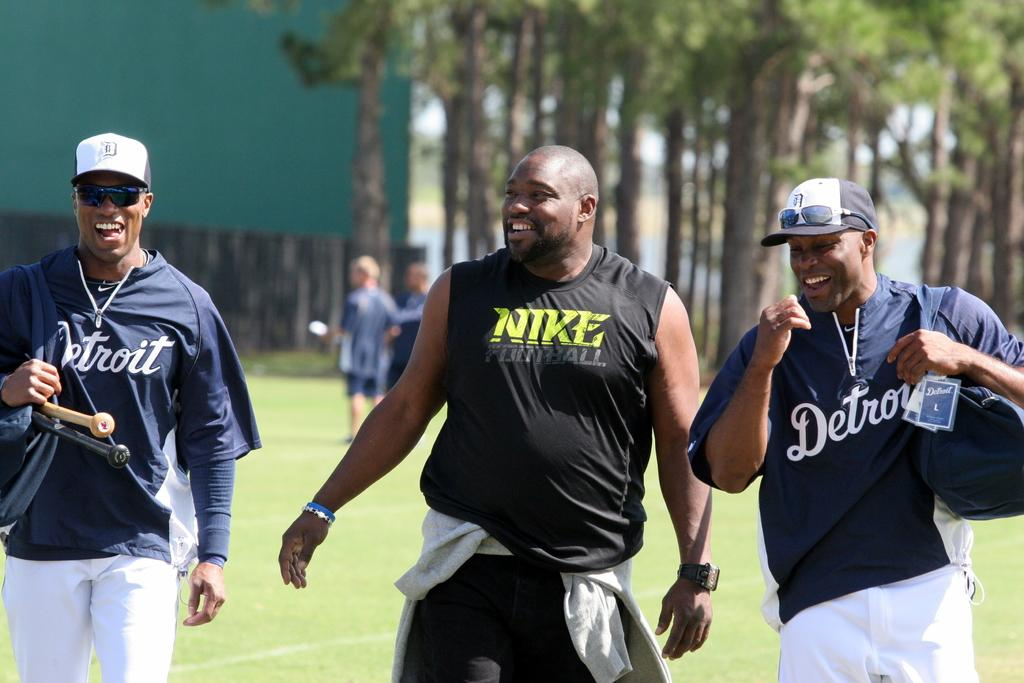Provide a one-sentence caption for the provided image. Some athletes wear ball caps and Detroit jerseys and another man is clad in a Nike Football tank.. 